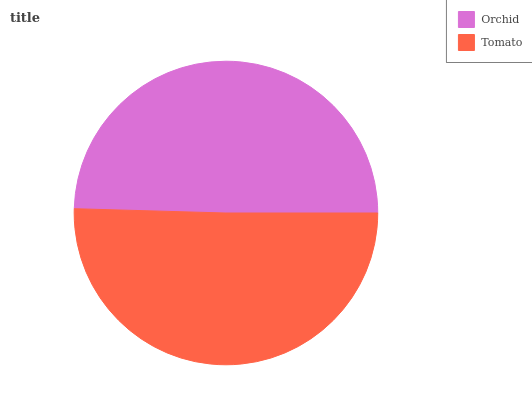Is Orchid the minimum?
Answer yes or no. Yes. Is Tomato the maximum?
Answer yes or no. Yes. Is Tomato the minimum?
Answer yes or no. No. Is Tomato greater than Orchid?
Answer yes or no. Yes. Is Orchid less than Tomato?
Answer yes or no. Yes. Is Orchid greater than Tomato?
Answer yes or no. No. Is Tomato less than Orchid?
Answer yes or no. No. Is Tomato the high median?
Answer yes or no. Yes. Is Orchid the low median?
Answer yes or no. Yes. Is Orchid the high median?
Answer yes or no. No. Is Tomato the low median?
Answer yes or no. No. 